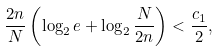Convert formula to latex. <formula><loc_0><loc_0><loc_500><loc_500>\frac { 2 n } { N } \left ( \log _ { 2 } e + \log _ { 2 } \frac { N } { 2 n } \right ) < \frac { c _ { 1 } } { 2 } ,</formula> 